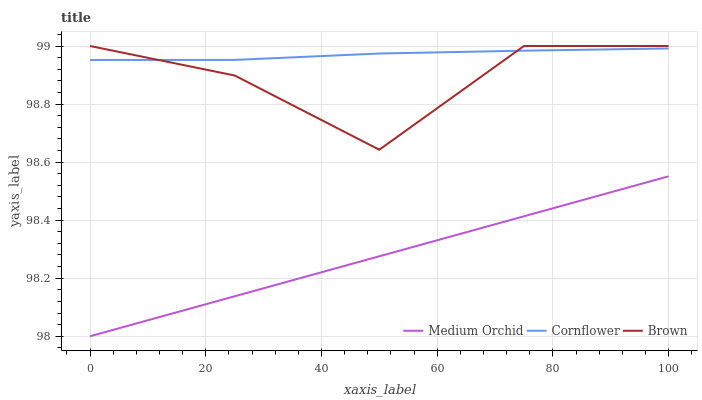Does Brown have the minimum area under the curve?
Answer yes or no. No. Does Brown have the maximum area under the curve?
Answer yes or no. No. Is Brown the smoothest?
Answer yes or no. No. Is Medium Orchid the roughest?
Answer yes or no. No. Does Brown have the lowest value?
Answer yes or no. No. Does Medium Orchid have the highest value?
Answer yes or no. No. Is Medium Orchid less than Brown?
Answer yes or no. Yes. Is Cornflower greater than Medium Orchid?
Answer yes or no. Yes. Does Medium Orchid intersect Brown?
Answer yes or no. No. 